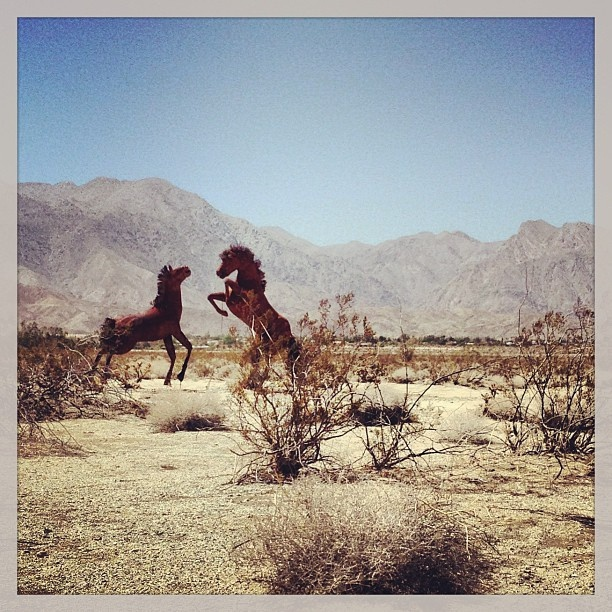Describe the objects in this image and their specific colors. I can see horse in darkgray, maroon, black, and brown tones and horse in darkgray, black, maroon, and brown tones in this image. 